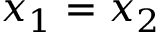<formula> <loc_0><loc_0><loc_500><loc_500>x _ { 1 } = x _ { 2 }</formula> 